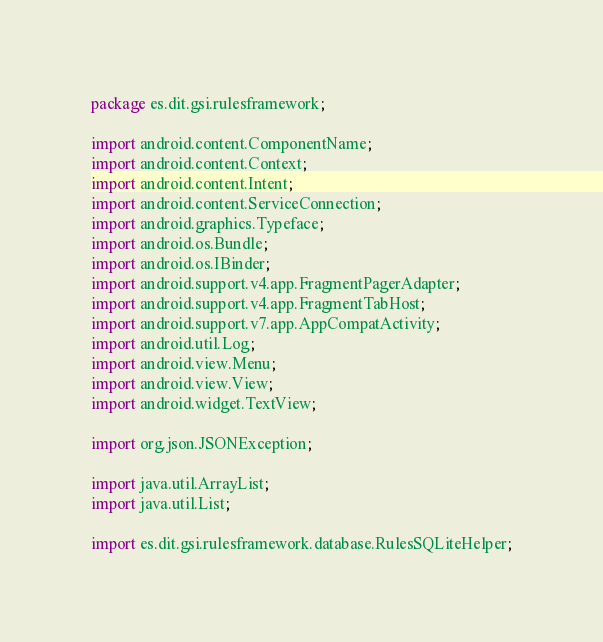Convert code to text. <code><loc_0><loc_0><loc_500><loc_500><_Java_>package es.dit.gsi.rulesframework;

import android.content.ComponentName;
import android.content.Context;
import android.content.Intent;
import android.content.ServiceConnection;
import android.graphics.Typeface;
import android.os.Bundle;
import android.os.IBinder;
import android.support.v4.app.FragmentPagerAdapter;
import android.support.v4.app.FragmentTabHost;
import android.support.v7.app.AppCompatActivity;
import android.util.Log;
import android.view.Menu;
import android.view.View;
import android.widget.TextView;

import org.json.JSONException;

import java.util.ArrayList;
import java.util.List;

import es.dit.gsi.rulesframework.database.RulesSQLiteHelper;</code> 